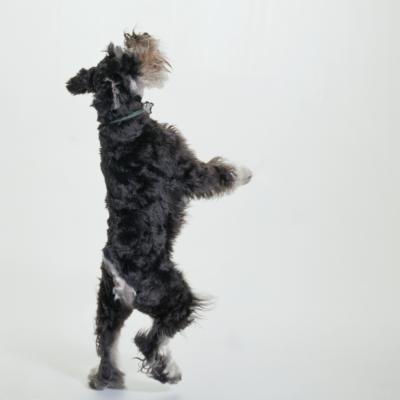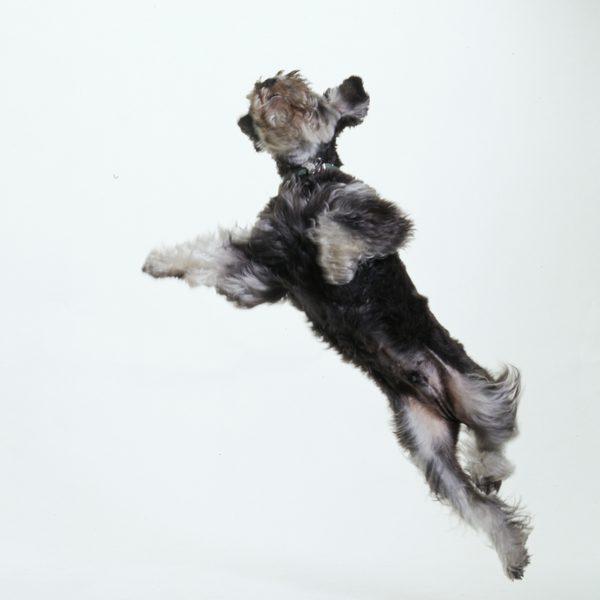The first image is the image on the left, the second image is the image on the right. Evaluate the accuracy of this statement regarding the images: "The dog in the image on the right is standing on all fours.". Is it true? Answer yes or no. No. The first image is the image on the left, the second image is the image on the right. Given the left and right images, does the statement "One camera-gazing schnauzer is standing on all fours on a surface that looks like cement." hold true? Answer yes or no. No. 